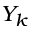<formula> <loc_0><loc_0><loc_500><loc_500>Y _ { k }</formula> 